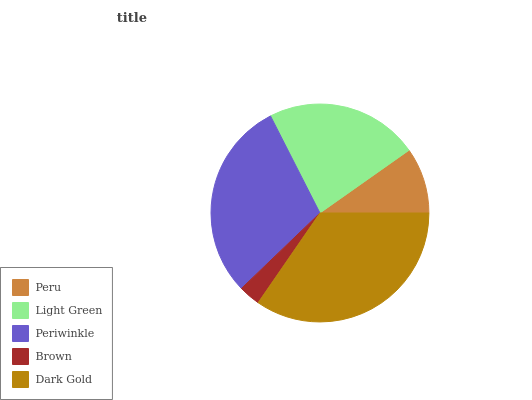Is Brown the minimum?
Answer yes or no. Yes. Is Dark Gold the maximum?
Answer yes or no. Yes. Is Light Green the minimum?
Answer yes or no. No. Is Light Green the maximum?
Answer yes or no. No. Is Light Green greater than Peru?
Answer yes or no. Yes. Is Peru less than Light Green?
Answer yes or no. Yes. Is Peru greater than Light Green?
Answer yes or no. No. Is Light Green less than Peru?
Answer yes or no. No. Is Light Green the high median?
Answer yes or no. Yes. Is Light Green the low median?
Answer yes or no. Yes. Is Periwinkle the high median?
Answer yes or no. No. Is Dark Gold the low median?
Answer yes or no. No. 